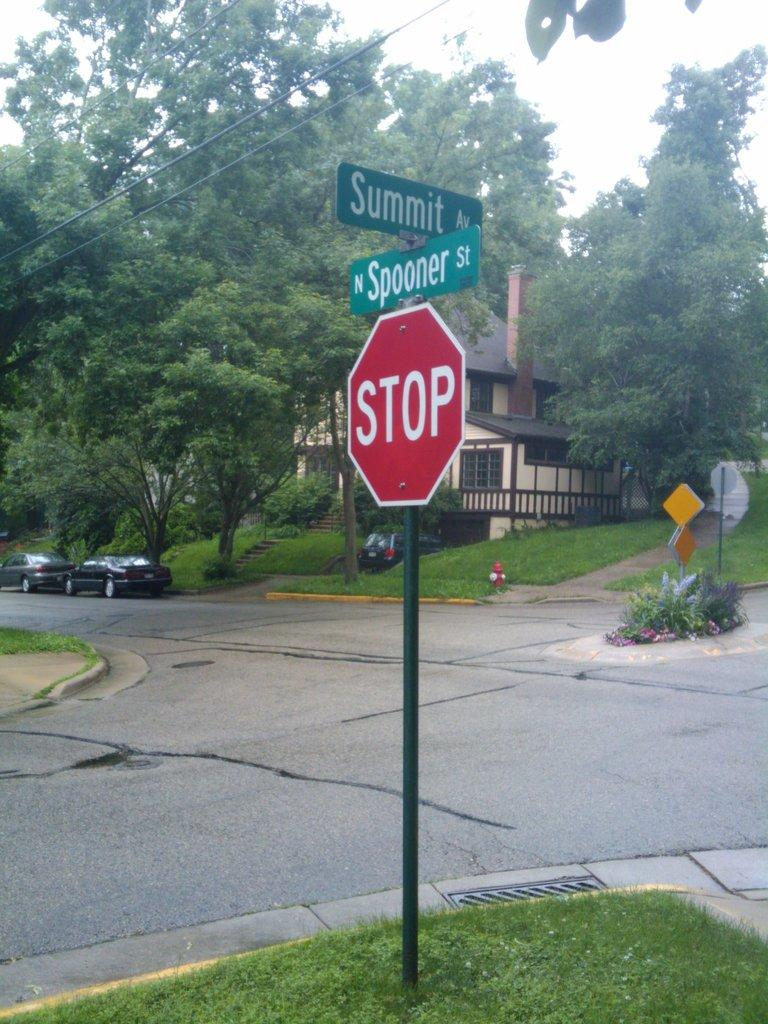<image>
Describe the image concisely. A stop sign at the intersection of Spooner St. and Summit Av. 